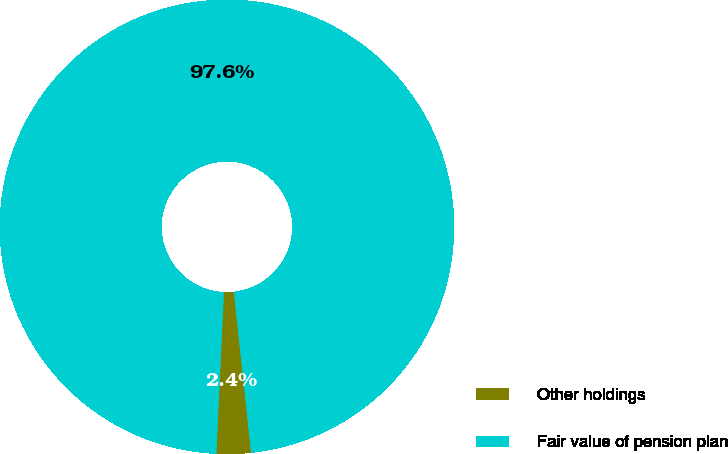<chart> <loc_0><loc_0><loc_500><loc_500><pie_chart><fcel>Other holdings<fcel>Fair value of pension plan<nl><fcel>2.44%<fcel>97.56%<nl></chart> 